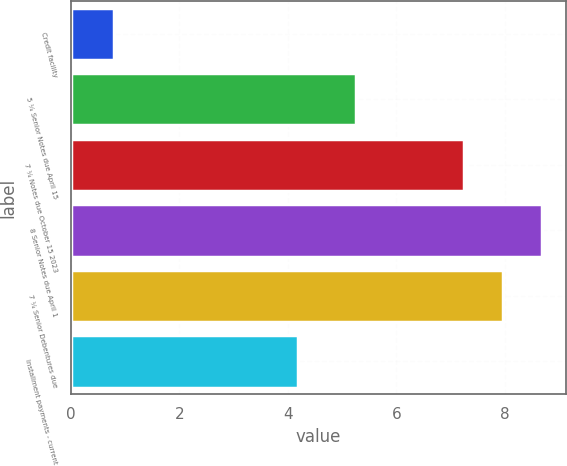Convert chart to OTSL. <chart><loc_0><loc_0><loc_500><loc_500><bar_chart><fcel>Credit facility<fcel>5 ¼ Senior Notes due April 15<fcel>7 ¼ Notes due October 15 2023<fcel>8 Senior Notes due April 1<fcel>7 ¼ Senior Debentures due<fcel>Installment payments - current<nl><fcel>0.8<fcel>5.25<fcel>7.25<fcel>8.69<fcel>7.97<fcel>4.18<nl></chart> 